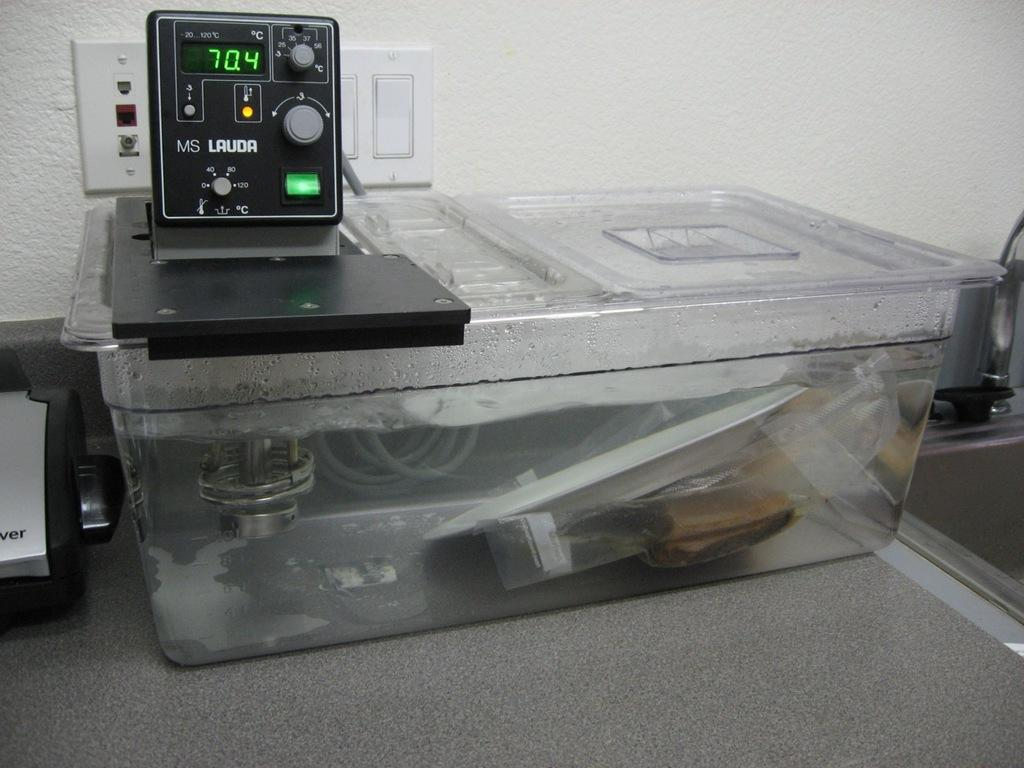<image>
Write a terse but informative summary of the picture. An electrical device that says MS Lauda is on top of a plastic bin of water. 